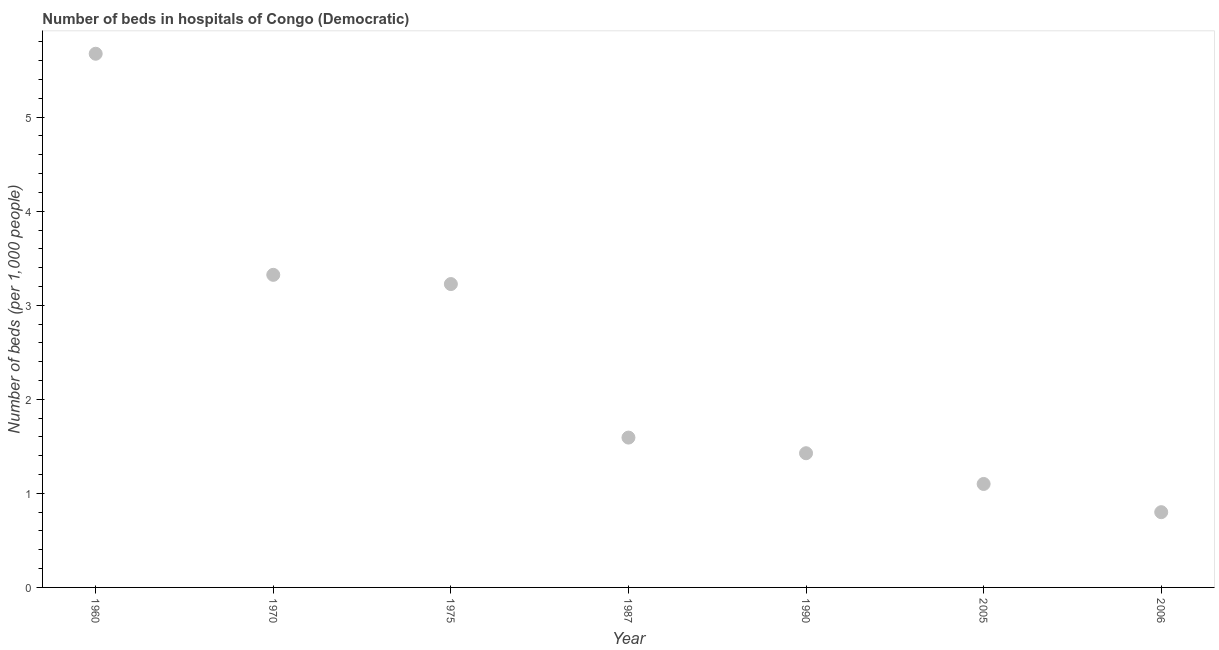What is the number of hospital beds in 1970?
Provide a succinct answer. 3.32. Across all years, what is the maximum number of hospital beds?
Make the answer very short. 5.67. In which year was the number of hospital beds maximum?
Make the answer very short. 1960. In which year was the number of hospital beds minimum?
Provide a succinct answer. 2006. What is the sum of the number of hospital beds?
Your answer should be compact. 17.14. What is the difference between the number of hospital beds in 1990 and 2005?
Your answer should be very brief. 0.33. What is the average number of hospital beds per year?
Provide a succinct answer. 2.45. What is the median number of hospital beds?
Make the answer very short. 1.59. What is the ratio of the number of hospital beds in 1960 to that in 2006?
Keep it short and to the point. 7.09. What is the difference between the highest and the second highest number of hospital beds?
Provide a succinct answer. 2.35. What is the difference between the highest and the lowest number of hospital beds?
Give a very brief answer. 4.87. How many dotlines are there?
Provide a succinct answer. 1. How many years are there in the graph?
Provide a succinct answer. 7. What is the difference between two consecutive major ticks on the Y-axis?
Your response must be concise. 1. Are the values on the major ticks of Y-axis written in scientific E-notation?
Provide a succinct answer. No. What is the title of the graph?
Your answer should be very brief. Number of beds in hospitals of Congo (Democratic). What is the label or title of the X-axis?
Ensure brevity in your answer.  Year. What is the label or title of the Y-axis?
Ensure brevity in your answer.  Number of beds (per 1,0 people). What is the Number of beds (per 1,000 people) in 1960?
Offer a very short reply. 5.67. What is the Number of beds (per 1,000 people) in 1970?
Provide a succinct answer. 3.32. What is the Number of beds (per 1,000 people) in 1975?
Ensure brevity in your answer.  3.23. What is the Number of beds (per 1,000 people) in 1987?
Provide a short and direct response. 1.59. What is the Number of beds (per 1,000 people) in 1990?
Your response must be concise. 1.43. What is the difference between the Number of beds (per 1,000 people) in 1960 and 1970?
Your answer should be very brief. 2.35. What is the difference between the Number of beds (per 1,000 people) in 1960 and 1975?
Your answer should be compact. 2.45. What is the difference between the Number of beds (per 1,000 people) in 1960 and 1987?
Your response must be concise. 4.08. What is the difference between the Number of beds (per 1,000 people) in 1960 and 1990?
Give a very brief answer. 4.25. What is the difference between the Number of beds (per 1,000 people) in 1960 and 2005?
Provide a short and direct response. 4.57. What is the difference between the Number of beds (per 1,000 people) in 1960 and 2006?
Your response must be concise. 4.87. What is the difference between the Number of beds (per 1,000 people) in 1970 and 1975?
Your answer should be compact. 0.1. What is the difference between the Number of beds (per 1,000 people) in 1970 and 1987?
Provide a short and direct response. 1.73. What is the difference between the Number of beds (per 1,000 people) in 1970 and 1990?
Give a very brief answer. 1.9. What is the difference between the Number of beds (per 1,000 people) in 1970 and 2005?
Make the answer very short. 2.22. What is the difference between the Number of beds (per 1,000 people) in 1970 and 2006?
Give a very brief answer. 2.52. What is the difference between the Number of beds (per 1,000 people) in 1975 and 1987?
Offer a very short reply. 1.63. What is the difference between the Number of beds (per 1,000 people) in 1975 and 1990?
Offer a very short reply. 1.8. What is the difference between the Number of beds (per 1,000 people) in 1975 and 2005?
Ensure brevity in your answer.  2.13. What is the difference between the Number of beds (per 1,000 people) in 1975 and 2006?
Keep it short and to the point. 2.43. What is the difference between the Number of beds (per 1,000 people) in 1987 and 1990?
Give a very brief answer. 0.17. What is the difference between the Number of beds (per 1,000 people) in 1987 and 2005?
Provide a succinct answer. 0.49. What is the difference between the Number of beds (per 1,000 people) in 1987 and 2006?
Ensure brevity in your answer.  0.79. What is the difference between the Number of beds (per 1,000 people) in 1990 and 2005?
Keep it short and to the point. 0.33. What is the difference between the Number of beds (per 1,000 people) in 1990 and 2006?
Your answer should be compact. 0.63. What is the difference between the Number of beds (per 1,000 people) in 2005 and 2006?
Ensure brevity in your answer.  0.3. What is the ratio of the Number of beds (per 1,000 people) in 1960 to that in 1970?
Keep it short and to the point. 1.71. What is the ratio of the Number of beds (per 1,000 people) in 1960 to that in 1975?
Ensure brevity in your answer.  1.76. What is the ratio of the Number of beds (per 1,000 people) in 1960 to that in 1987?
Make the answer very short. 3.56. What is the ratio of the Number of beds (per 1,000 people) in 1960 to that in 1990?
Give a very brief answer. 3.98. What is the ratio of the Number of beds (per 1,000 people) in 1960 to that in 2005?
Provide a succinct answer. 5.16. What is the ratio of the Number of beds (per 1,000 people) in 1960 to that in 2006?
Provide a short and direct response. 7.09. What is the ratio of the Number of beds (per 1,000 people) in 1970 to that in 1975?
Your response must be concise. 1.03. What is the ratio of the Number of beds (per 1,000 people) in 1970 to that in 1987?
Offer a terse response. 2.09. What is the ratio of the Number of beds (per 1,000 people) in 1970 to that in 1990?
Ensure brevity in your answer.  2.33. What is the ratio of the Number of beds (per 1,000 people) in 1970 to that in 2005?
Offer a terse response. 3.02. What is the ratio of the Number of beds (per 1,000 people) in 1970 to that in 2006?
Provide a succinct answer. 4.15. What is the ratio of the Number of beds (per 1,000 people) in 1975 to that in 1987?
Offer a terse response. 2.02. What is the ratio of the Number of beds (per 1,000 people) in 1975 to that in 1990?
Provide a succinct answer. 2.26. What is the ratio of the Number of beds (per 1,000 people) in 1975 to that in 2005?
Provide a short and direct response. 2.93. What is the ratio of the Number of beds (per 1,000 people) in 1975 to that in 2006?
Keep it short and to the point. 4.03. What is the ratio of the Number of beds (per 1,000 people) in 1987 to that in 1990?
Offer a terse response. 1.12. What is the ratio of the Number of beds (per 1,000 people) in 1987 to that in 2005?
Your answer should be very brief. 1.45. What is the ratio of the Number of beds (per 1,000 people) in 1987 to that in 2006?
Ensure brevity in your answer.  1.99. What is the ratio of the Number of beds (per 1,000 people) in 1990 to that in 2005?
Make the answer very short. 1.3. What is the ratio of the Number of beds (per 1,000 people) in 1990 to that in 2006?
Your answer should be very brief. 1.78. What is the ratio of the Number of beds (per 1,000 people) in 2005 to that in 2006?
Give a very brief answer. 1.38. 